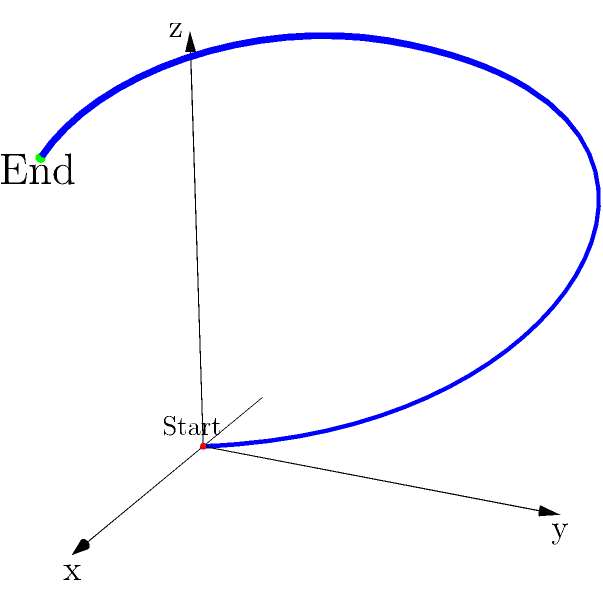As a writer documenting an ex-professional baseball player's journey, you're analyzing the trajectory of their signature pitch. From the side view (y-z plane), what shape would the path of the baseball most closely resemble? To answer this question, we need to consider the trajectory of the baseball pitch from the side view (y-z plane). Let's break it down step-by-step:

1. The given 3D graph shows the trajectory of the pitch from the pitcher's perspective.

2. The pitch starts at the origin (0,0,0) and ends at the point (2,0,4).

3. The highest point of the trajectory is approximately at (1,2,5).

4. To visualize the side view, we need to imagine looking at the y-z plane, essentially ignoring the x-axis.

5. From this perspective, we would see:
   - The ball starting low (z=0)
   - Rising to its highest point (z=5)
   - Then dropping slightly to its end point (z=4)

6. This path, when viewed from the side, would create an arc-like shape.

7. In baseball terminology, this type of trajectory is often referred to as a "rise and fall" or "hump" in the pitch.

8. Mathematically, this shape most closely resembles a parabola, which is the typical path of a projectile under the influence of gravity and initial velocity.

Therefore, from the side view (y-z plane), the path of the baseball would most closely resemble a parabolic arc.
Answer: Parabolic arc 